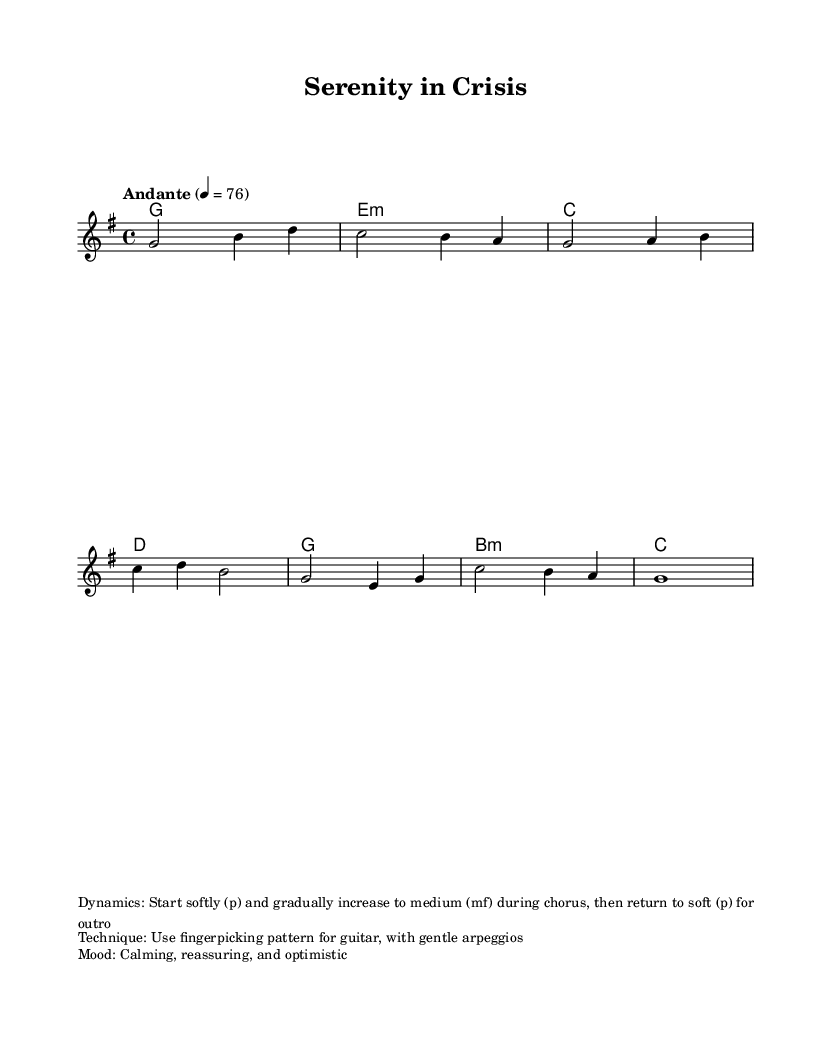What is the key signature of this music? The key signature is G major, which has one sharp (F#). This can be determined from the key signature indicated at the beginning of the score.
Answer: G major What is the time signature of this piece? The time signature is 4/4, which indicates that there are four beats in each measure and the quarter note gets one beat. This is shown at the beginning of the score.
Answer: 4/4 What is the tempo marking for this piece? The tempo marking is "Andante" at a speed of 76 beats per minute, which can be found in the global settings at the start of the score.
Answer: Andante 4 = 76 What dynamics should be used in this piece? The dynamics indicate to start softly (p) and gradually increase to medium (mf) during the chorus, then return to soft (p) for the outro. This can be seen in the dynamics markup provided.
Answer: Start softly (p) What type of guitar technique is recommended for this piece? The recommended guitar technique is fingerpicking with gentle arpeggios, as indicated in the markup section that outlines performance techniques.
Answer: Fingerpicking What overall mood does this piece convey? The mood described in the markup section is calming, reassuring, and optimistic, reflecting the intent behind the melody and harmonies throughout the score.
Answer: Calming, reassuring, and optimistic How many measures are present in the melody? The melody consists of eight measures, which can be counted from the layout of the notes displayed. Each measure is separated by a vertical line and contains a sequence of notes.
Answer: Eight measures 